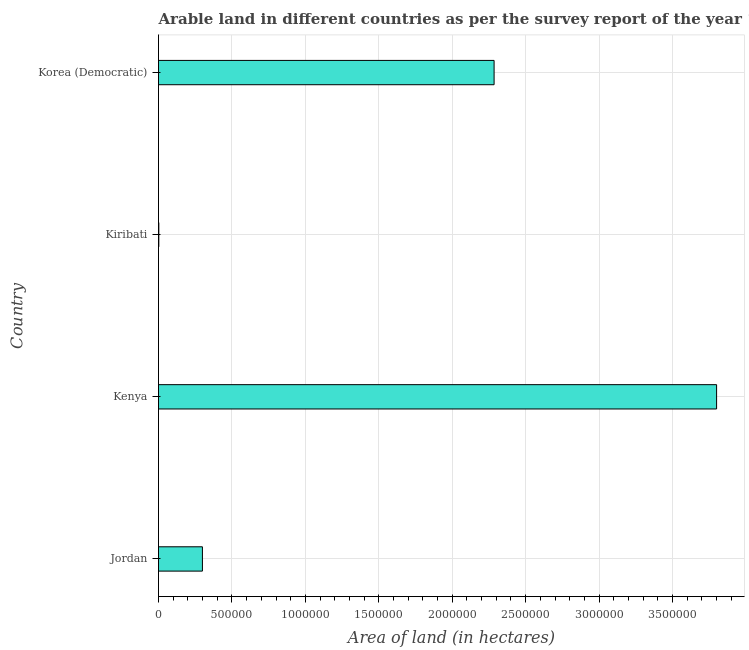Does the graph contain grids?
Provide a short and direct response. Yes. What is the title of the graph?
Give a very brief answer. Arable land in different countries as per the survey report of the year 1980. What is the label or title of the X-axis?
Provide a succinct answer. Area of land (in hectares). What is the label or title of the Y-axis?
Give a very brief answer. Country. What is the area of land in Kenya?
Your response must be concise. 3.80e+06. Across all countries, what is the maximum area of land?
Give a very brief answer. 3.80e+06. Across all countries, what is the minimum area of land?
Your answer should be very brief. 2000. In which country was the area of land maximum?
Offer a very short reply. Kenya. In which country was the area of land minimum?
Keep it short and to the point. Kiribati. What is the sum of the area of land?
Offer a terse response. 6.39e+06. What is the difference between the area of land in Kenya and Kiribati?
Your answer should be compact. 3.80e+06. What is the average area of land per country?
Ensure brevity in your answer.  1.60e+06. What is the median area of land?
Ensure brevity in your answer.  1.29e+06. What is the ratio of the area of land in Kiribati to that in Korea (Democratic)?
Give a very brief answer. 0. Is the difference between the area of land in Jordan and Korea (Democratic) greater than the difference between any two countries?
Give a very brief answer. No. What is the difference between the highest and the second highest area of land?
Give a very brief answer. 1.52e+06. What is the difference between the highest and the lowest area of land?
Your answer should be compact. 3.80e+06. How many bars are there?
Provide a short and direct response. 4. How many countries are there in the graph?
Provide a short and direct response. 4. What is the difference between two consecutive major ticks on the X-axis?
Give a very brief answer. 5.00e+05. Are the values on the major ticks of X-axis written in scientific E-notation?
Make the answer very short. No. What is the Area of land (in hectares) of Jordan?
Your response must be concise. 2.99e+05. What is the Area of land (in hectares) of Kenya?
Provide a succinct answer. 3.80e+06. What is the Area of land (in hectares) of Korea (Democratic)?
Keep it short and to the point. 2.28e+06. What is the difference between the Area of land (in hectares) in Jordan and Kenya?
Provide a succinct answer. -3.50e+06. What is the difference between the Area of land (in hectares) in Jordan and Kiribati?
Your answer should be compact. 2.97e+05. What is the difference between the Area of land (in hectares) in Jordan and Korea (Democratic)?
Make the answer very short. -1.99e+06. What is the difference between the Area of land (in hectares) in Kenya and Kiribati?
Your response must be concise. 3.80e+06. What is the difference between the Area of land (in hectares) in Kenya and Korea (Democratic)?
Offer a terse response. 1.52e+06. What is the difference between the Area of land (in hectares) in Kiribati and Korea (Democratic)?
Ensure brevity in your answer.  -2.28e+06. What is the ratio of the Area of land (in hectares) in Jordan to that in Kenya?
Make the answer very short. 0.08. What is the ratio of the Area of land (in hectares) in Jordan to that in Kiribati?
Provide a succinct answer. 149.5. What is the ratio of the Area of land (in hectares) in Jordan to that in Korea (Democratic)?
Offer a very short reply. 0.13. What is the ratio of the Area of land (in hectares) in Kenya to that in Kiribati?
Your answer should be very brief. 1900. What is the ratio of the Area of land (in hectares) in Kenya to that in Korea (Democratic)?
Keep it short and to the point. 1.66. 